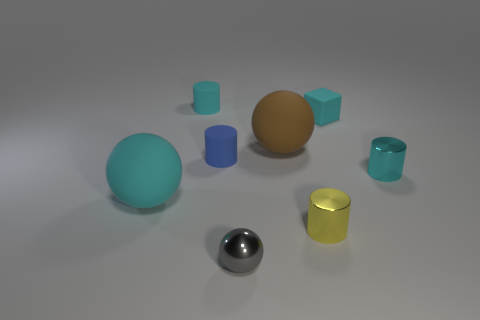Subtract all small yellow shiny cylinders. How many cylinders are left? 3 Subtract all yellow cylinders. How many cylinders are left? 3 Subtract all red cylinders. Subtract all green cubes. How many cylinders are left? 4 Add 1 yellow shiny cylinders. How many objects exist? 9 Subtract all blocks. How many objects are left? 7 Subtract all green matte cylinders. Subtract all rubber cylinders. How many objects are left? 6 Add 2 blue rubber cylinders. How many blue rubber cylinders are left? 3 Add 8 gray shiny spheres. How many gray shiny spheres exist? 9 Subtract 1 cyan spheres. How many objects are left? 7 